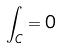<formula> <loc_0><loc_0><loc_500><loc_500>\int _ { C } = 0</formula> 